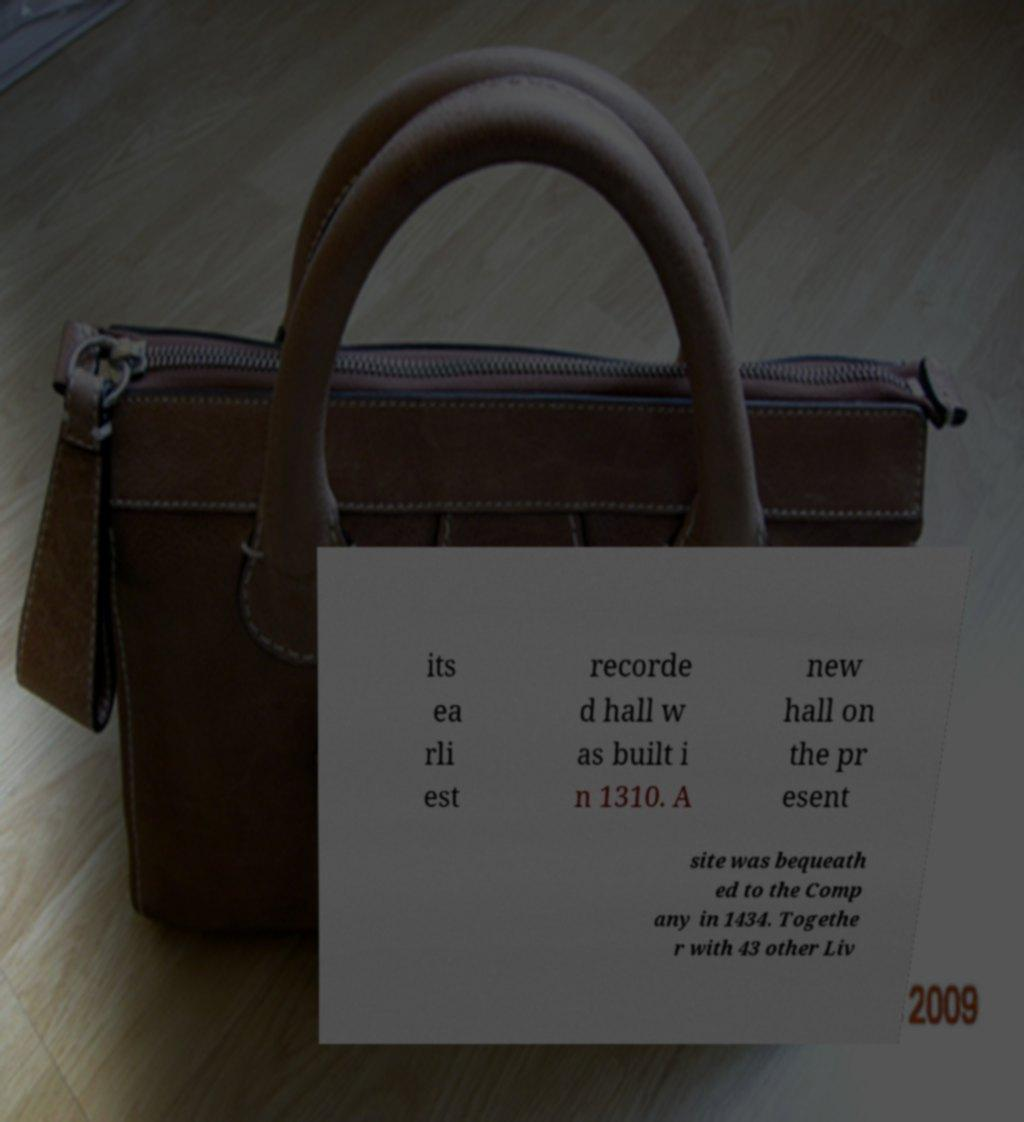Could you assist in decoding the text presented in this image and type it out clearly? its ea rli est recorde d hall w as built i n 1310. A new hall on the pr esent site was bequeath ed to the Comp any in 1434. Togethe r with 43 other Liv 